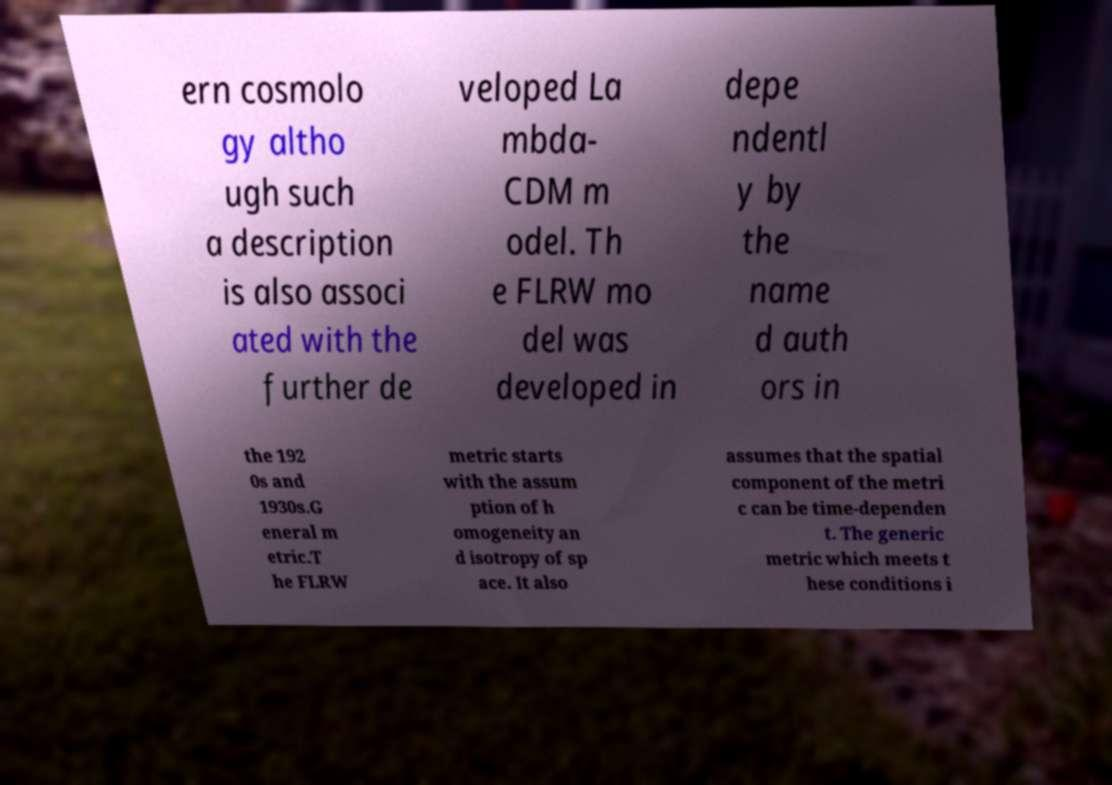For documentation purposes, I need the text within this image transcribed. Could you provide that? ern cosmolo gy altho ugh such a description is also associ ated with the further de veloped La mbda- CDM m odel. Th e FLRW mo del was developed in depe ndentl y by the name d auth ors in the 192 0s and 1930s.G eneral m etric.T he FLRW metric starts with the assum ption of h omogeneity an d isotropy of sp ace. It also assumes that the spatial component of the metri c can be time-dependen t. The generic metric which meets t hese conditions i 